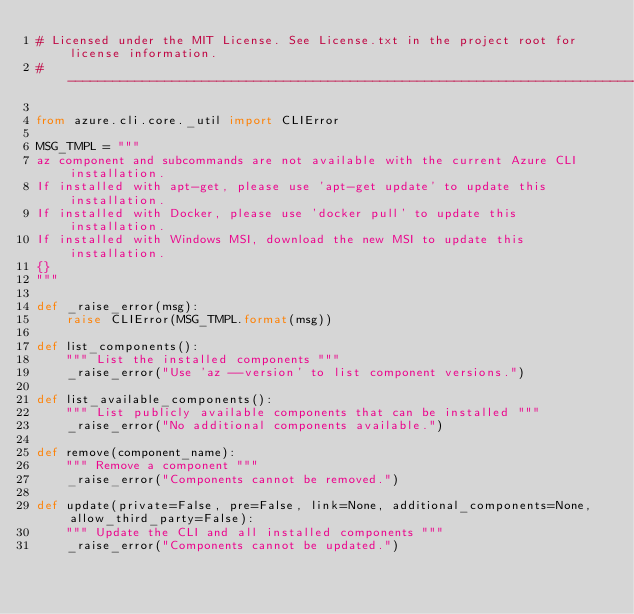<code> <loc_0><loc_0><loc_500><loc_500><_Python_># Licensed under the MIT License. See License.txt in the project root for license information.
# --------------------------------------------------------------------------------------------

from azure.cli.core._util import CLIError

MSG_TMPL = """
az component and subcommands are not available with the current Azure CLI installation.
If installed with apt-get, please use 'apt-get update' to update this installation.
If installed with Docker, please use 'docker pull' to update this installation.
If installed with Windows MSI, download the new MSI to update this installation.
{}
"""

def _raise_error(msg):
    raise CLIError(MSG_TMPL.format(msg))

def list_components():
    """ List the installed components """
    _raise_error("Use 'az --version' to list component versions.")

def list_available_components():
    """ List publicly available components that can be installed """
    _raise_error("No additional components available.")

def remove(component_name):
    """ Remove a component """
    _raise_error("Components cannot be removed.")

def update(private=False, pre=False, link=None, additional_components=None, allow_third_party=False):
    """ Update the CLI and all installed components """
    _raise_error("Components cannot be updated.")
</code> 